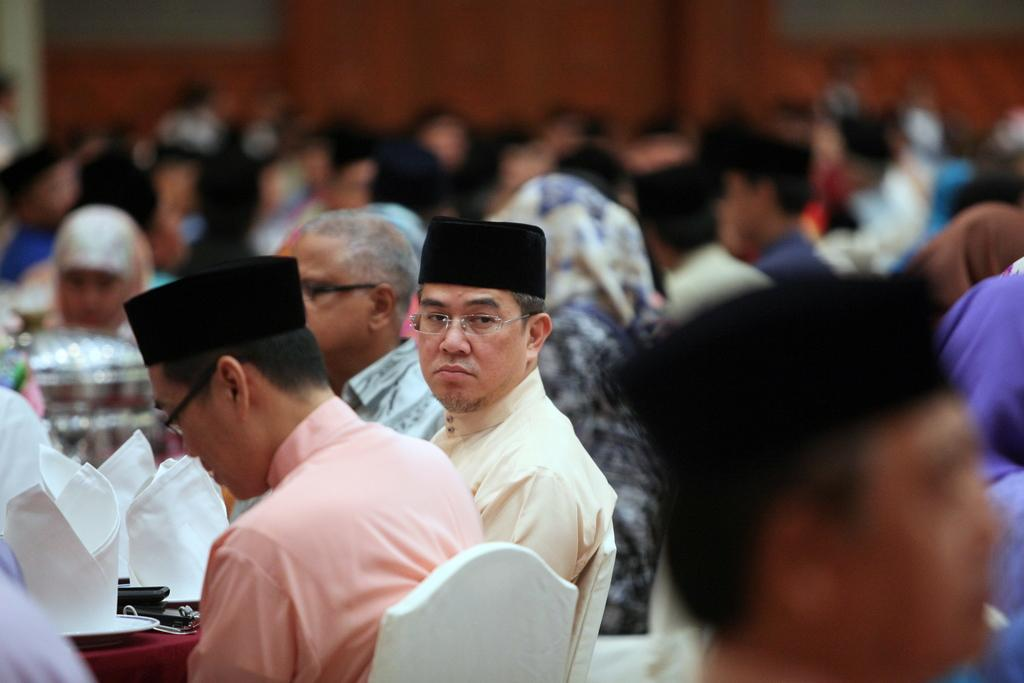What are the people in the image doing? The persons in the image are sitting on chairs. Can you describe the background of the image? The background of the image is blurred. How many geese are visible in the image? There are no geese present in the image. What type of food is being served to the persons sitting on chairs? The provided facts do not mention any food being served in the image. 